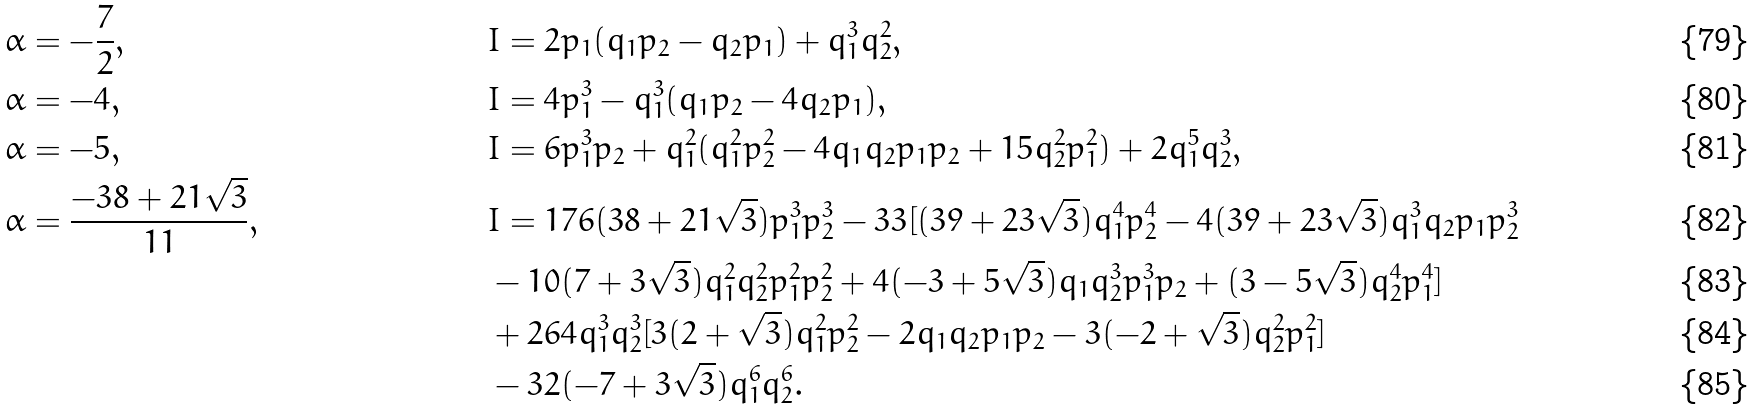<formula> <loc_0><loc_0><loc_500><loc_500>\alpha & = - \frac { 7 } { 2 } , & & I = 2 p _ { 1 } ( q _ { 1 } p _ { 2 } - q _ { 2 } p _ { 1 } ) + q _ { 1 } ^ { 3 } q _ { 2 } ^ { 2 } , \\ \alpha & = - 4 , & & I = 4 p _ { 1 } ^ { 3 } - q _ { 1 } ^ { 3 } ( q _ { 1 } p _ { 2 } - 4 q _ { 2 } p _ { 1 } ) , \\ \alpha & = - 5 , & & I = 6 p _ { 1 } ^ { 3 } p _ { 2 } + q _ { 1 } ^ { 2 } ( q _ { 1 } ^ { 2 } p _ { 2 } ^ { 2 } - 4 q _ { 1 } q _ { 2 } p _ { 1 } p _ { 2 } + 1 5 q _ { 2 } ^ { 2 } p _ { 1 } ^ { 2 } ) + 2 q _ { 1 } ^ { 5 } q _ { 2 } ^ { 3 } , \\ \alpha & = \frac { - 3 8 + 2 1 \sqrt { 3 } } { 1 1 } , & & I = 1 7 6 ( 3 8 + 2 1 \sqrt { 3 } ) p _ { 1 } ^ { 3 } p _ { 2 } ^ { 3 } - 3 3 [ ( 3 9 + 2 3 \sqrt { 3 } ) q _ { 1 } ^ { 4 } p _ { 2 } ^ { 4 } - 4 ( 3 9 + 2 3 \sqrt { 3 } ) q _ { 1 } ^ { 3 } q _ { 2 } p _ { 1 } p _ { 2 } ^ { 3 } \\ & & & - 1 0 ( 7 + 3 \sqrt { 3 } ) q _ { 1 } ^ { 2 } q _ { 2 } ^ { 2 } p _ { 1 } ^ { 2 } p _ { 2 } ^ { 2 } + 4 ( - 3 + 5 \sqrt { 3 } ) q _ { 1 } q _ { 2 } ^ { 3 } p _ { 1 } ^ { 3 } p _ { 2 } + ( 3 - 5 \sqrt { 3 } ) q _ { 2 } ^ { 4 } p _ { 1 } ^ { 4 } ] \\ & & & + 2 6 4 q _ { 1 } ^ { 3 } q _ { 2 } ^ { 3 } [ 3 ( 2 + \sqrt { 3 } ) q _ { 1 } ^ { 2 } p _ { 2 } ^ { 2 } - 2 q _ { 1 } q _ { 2 } p _ { 1 } p _ { 2 } - 3 ( - 2 + \sqrt { 3 } ) q _ { 2 } ^ { 2 } p _ { 1 } ^ { 2 } ] \\ & & & - 3 2 ( - 7 + 3 \sqrt { 3 } ) q _ { 1 } ^ { 6 } q _ { 2 } ^ { 6 } .</formula> 